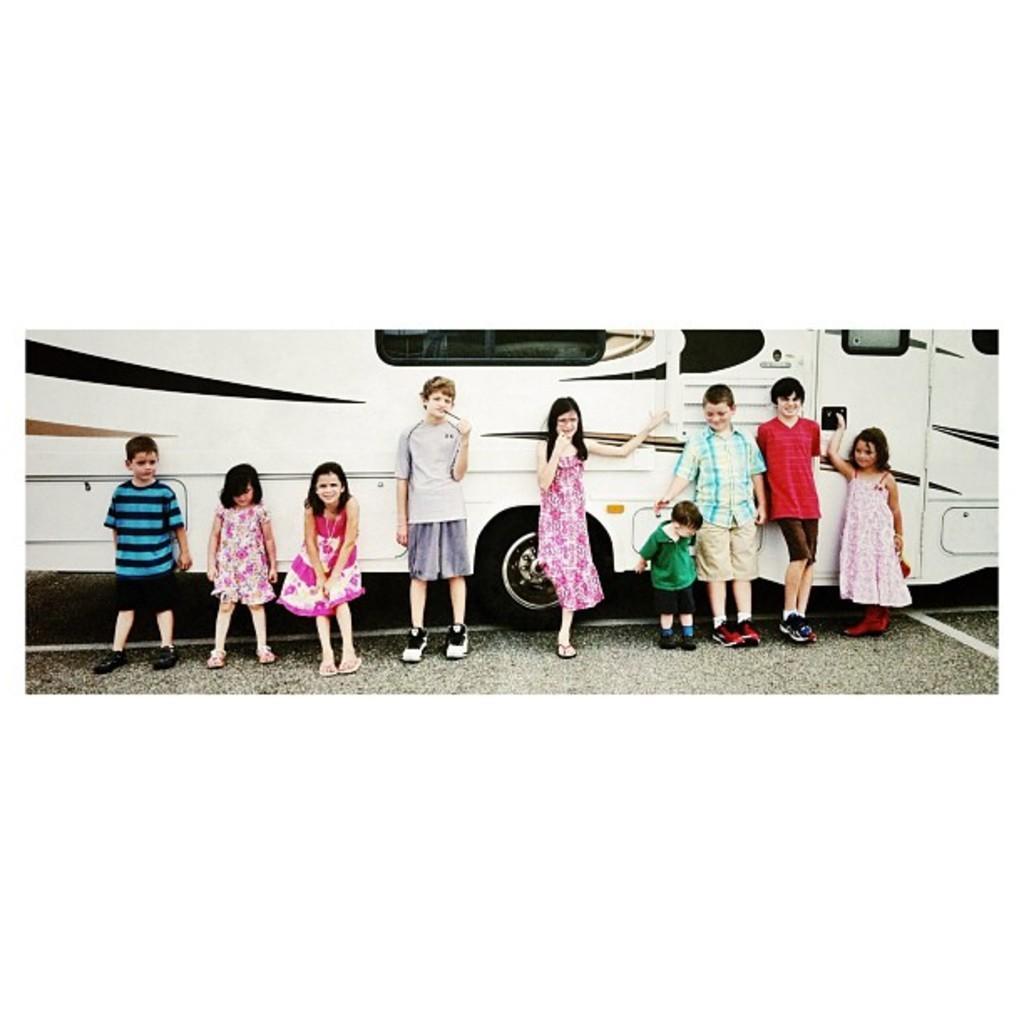In one or two sentences, can you explain what this image depicts? In this image we can see a group of children standing on the road. We can also see a bus on the road. 